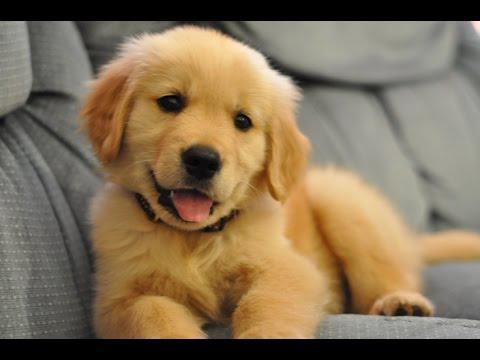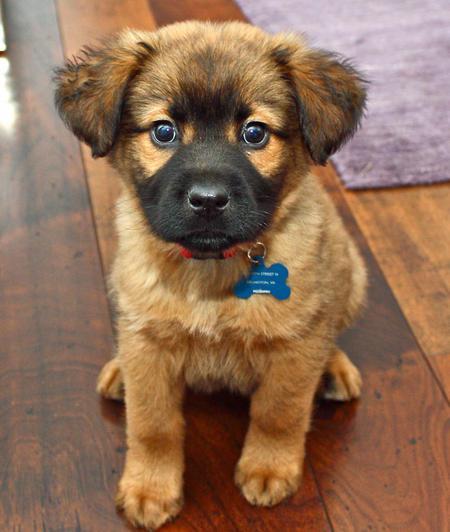The first image is the image on the left, the second image is the image on the right. For the images displayed, is the sentence "The dogs on the left are facing right." factually correct? Answer yes or no. No. 